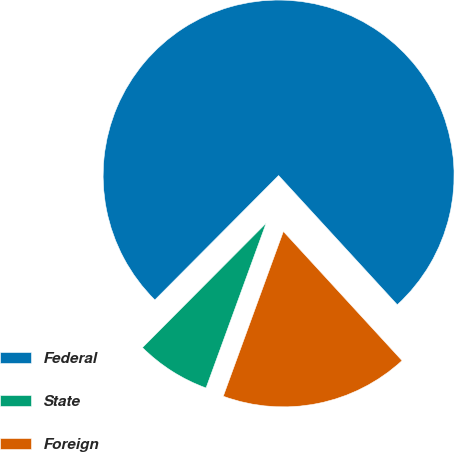Convert chart to OTSL. <chart><loc_0><loc_0><loc_500><loc_500><pie_chart><fcel>Federal<fcel>State<fcel>Foreign<nl><fcel>75.72%<fcel>6.89%<fcel>17.39%<nl></chart> 